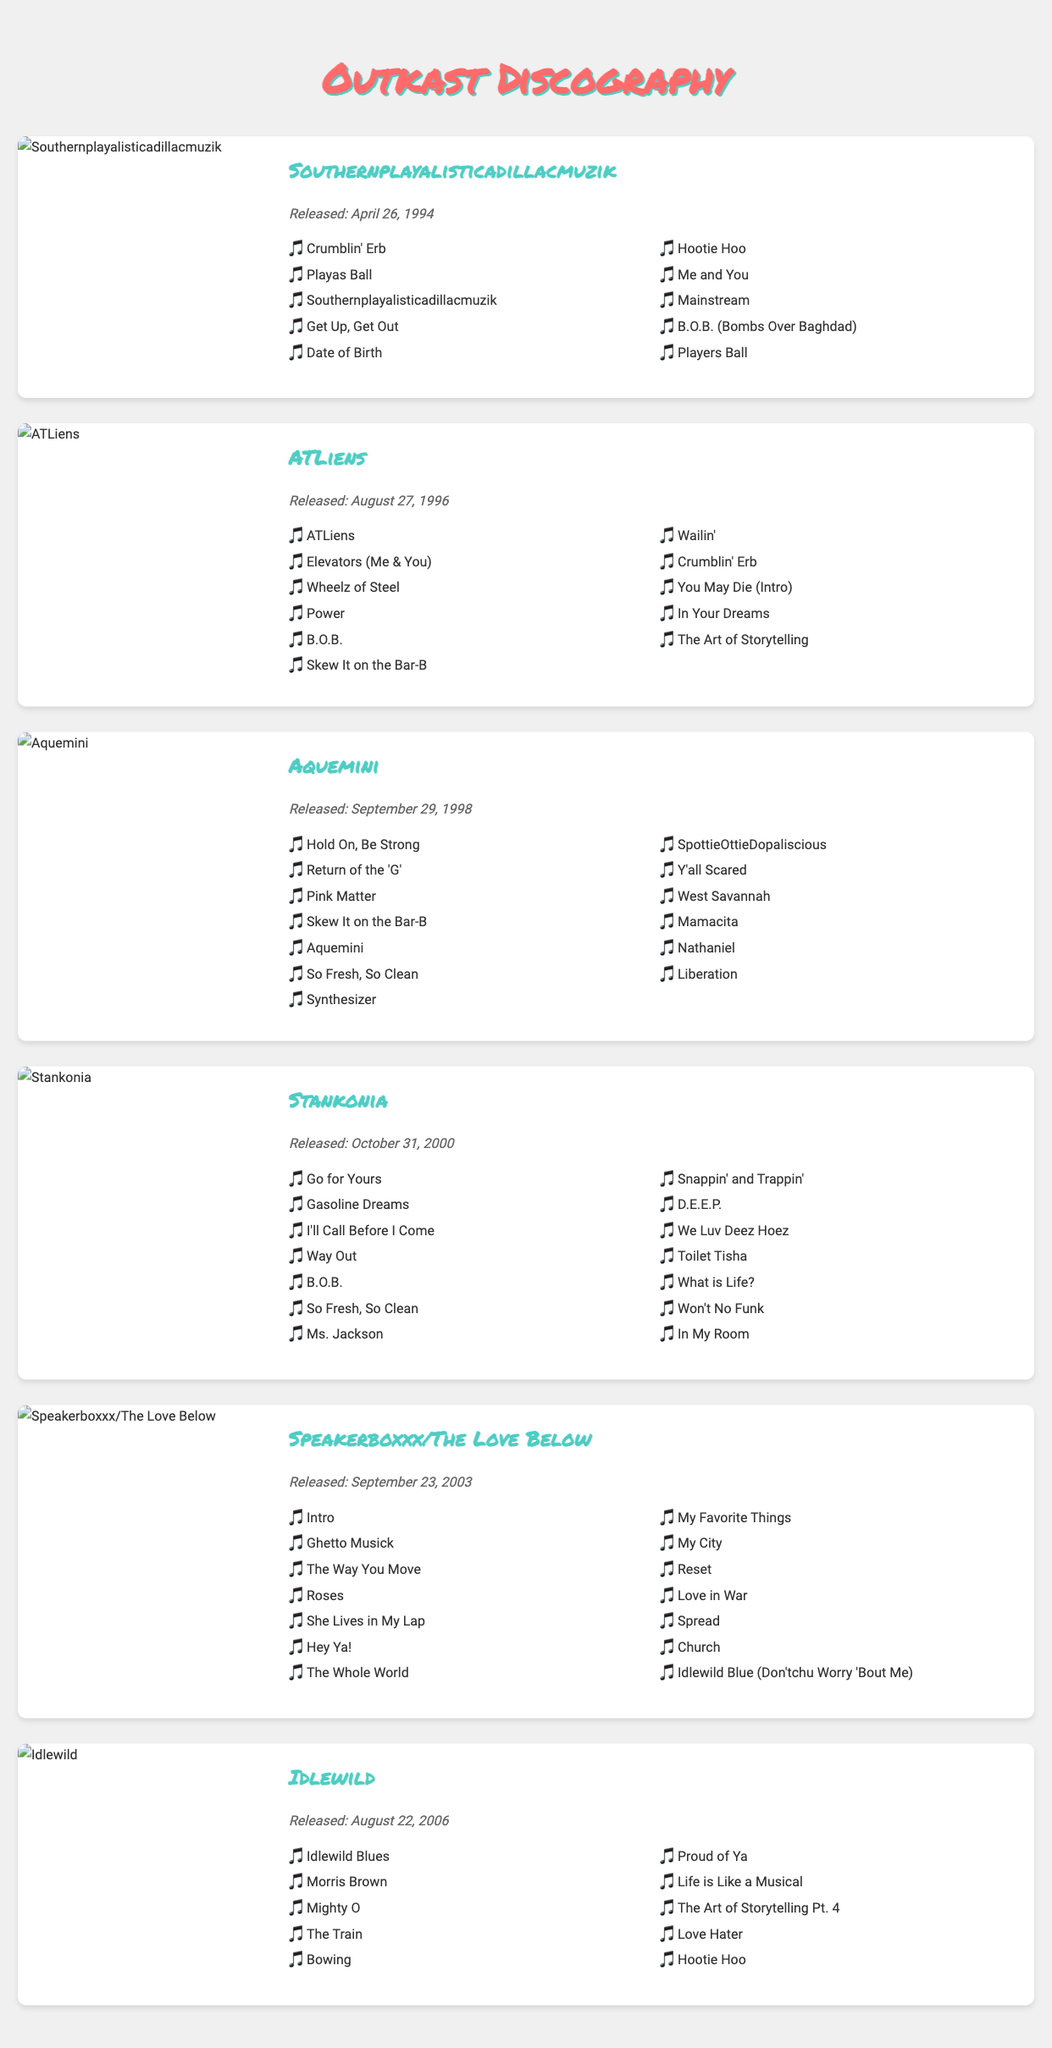What is the title of Outkast's debut album? The debut album of Outkast is mentioned in the document as "Southernplayalisticadillacmuzik."
Answer: Southernplayalisticadillacmuzik What is the release date of the album "Aquemini"? The release date for "Aquemini" is given in the document, which is September 29, 1998.
Answer: September 29, 1998 How many tracks are there in "Speakerboxxx/The Love Below"? The document lists 14 tracks under "Speakerboxxx/The Love Below."
Answer: 14 Which album features the song "Ms. Jackson"? The song "Ms. Jackson" is listed in the track listing for the album "Stankonia."
Answer: Stankonia What year was "Idlewild" released? The release date for "Idlewild" is specified as August 22, 2006.
Answer: 2006 What is the name of the song listed last in "ATLiens"? The last song listed in "ATLiens" is "The Art of Storytelling."
Answer: The Art of Storytelling Which album features both "B.O.B." and "So Fresh, So Clean"? The album that includes both "B.O.B." and "So Fresh, So Clean" is "Stankonia."
Answer: Stankonia Which album cover uses a green color palette predominantly? The album cover that features a prominent green color palette is "Speakerboxxx/The Love Below."
Answer: Speakerboxxx/The Love Below What is the title of the song that opens "Idlewild"? The opening song of "Idlewild" is titled "Idlewild Blues."
Answer: Idlewild Blues 